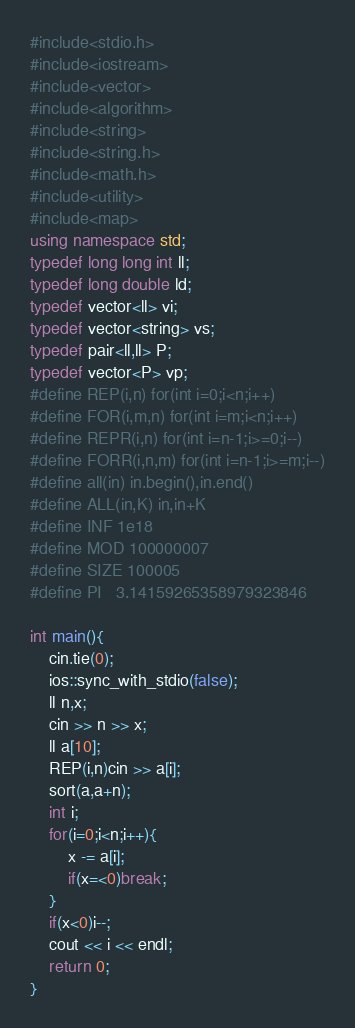<code> <loc_0><loc_0><loc_500><loc_500><_C++_>#include<stdio.h>
#include<iostream>
#include<vector>
#include<algorithm>
#include<string>
#include<string.h>
#include<math.h>
#include<utility>
#include<map>
using namespace std;
typedef long long int ll;
typedef long double ld;
typedef vector<ll> vi;
typedef vector<string> vs;
typedef pair<ll,ll> P;
typedef vector<P> vp;
#define REP(i,n) for(int i=0;i<n;i++)
#define FOR(i,m,n) for(int i=m;i<n;i++)
#define REPR(i,n) for(int i=n-1;i>=0;i--)
#define FORR(i,n,m) for(int i=n-1;i>=m;i--)
#define all(in) in.begin(),in.end()
#define ALL(in,K) in,in+K
#define INF 1e18
#define MOD 100000007
#define SIZE 100005
#define PI 	3.14159265358979323846

int main(){
    cin.tie(0);
    ios::sync_with_stdio(false);
    ll n,x;
    cin >> n >> x;
    ll a[10];
    REP(i,n)cin >> a[i];
    sort(a,a+n);
    int i;
    for(i=0;i<n;i++){
        x -= a[i];
        if(x=<0)break;
    }
    if(x<0)i--;
    cout << i << endl;
    return 0;
}</code> 